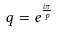<formula> <loc_0><loc_0><loc_500><loc_500>\ q = e ^ { \frac { i \pi } { p } }</formula> 